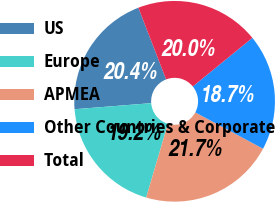<chart> <loc_0><loc_0><loc_500><loc_500><pie_chart><fcel>US<fcel>Europe<fcel>APMEA<fcel>Other Countries & Corporate<fcel>Total<nl><fcel>20.38%<fcel>19.17%<fcel>21.74%<fcel>18.72%<fcel>19.99%<nl></chart> 